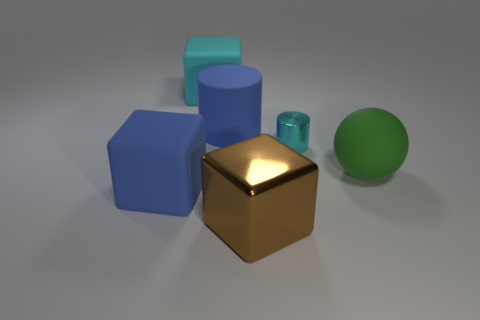How does the perspective affect the composition of these objects? The perspective used creates a sense of depth and allows the objects to be arranged in a way that leads the eye across the image. It also emphasizes the comparative sizes and shapes of the objects, enhancing the visual interest of this 3D render. 